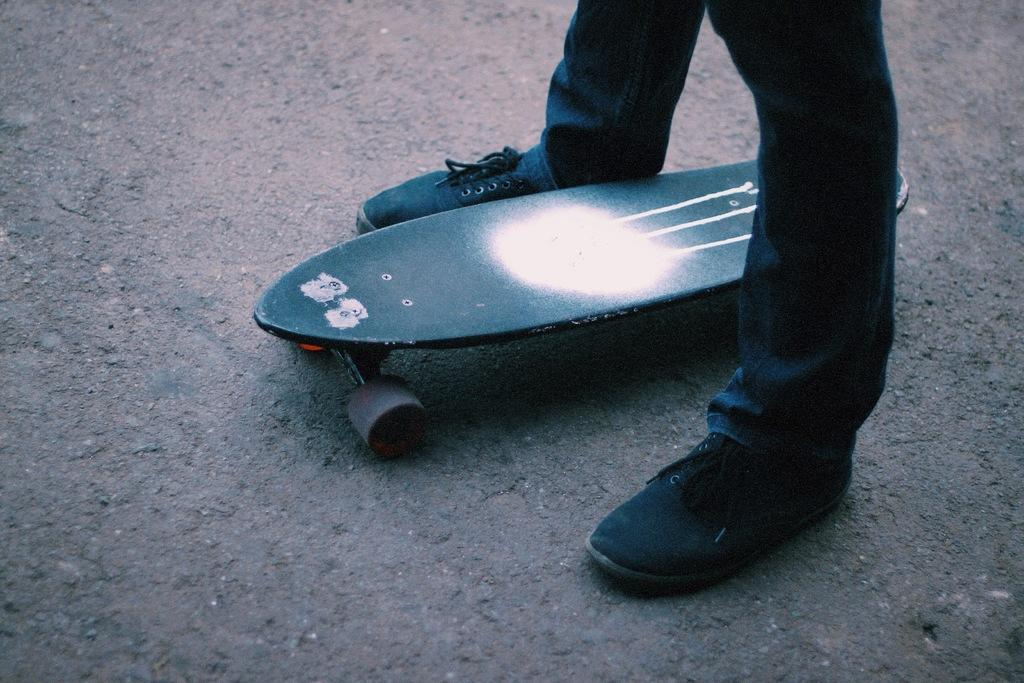What is the main subject of the image? There is a person standing in the image. What type of clothing is the person wearing? The person is wearing trousers and shoes. What object is located in the middle of the image? There is a skateboard in the middle of the image. How many pigs are visible on the skateboard in the image? There are no pigs present in the image, and therefore none can be seen on the skateboard. 